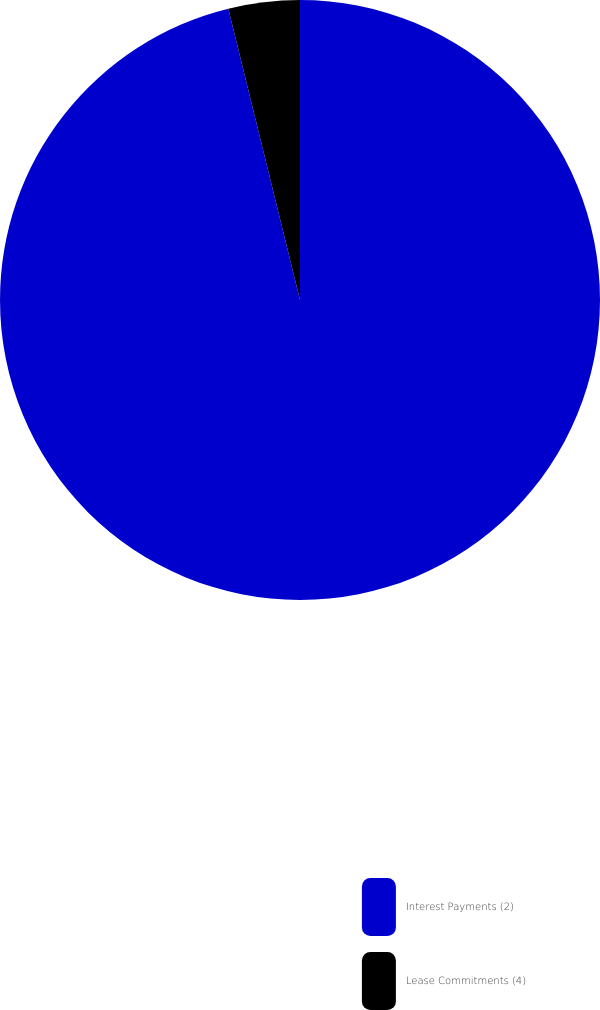Convert chart to OTSL. <chart><loc_0><loc_0><loc_500><loc_500><pie_chart><fcel>Interest Payments (2)<fcel>Lease Commitments (4)<nl><fcel>96.16%<fcel>3.84%<nl></chart> 